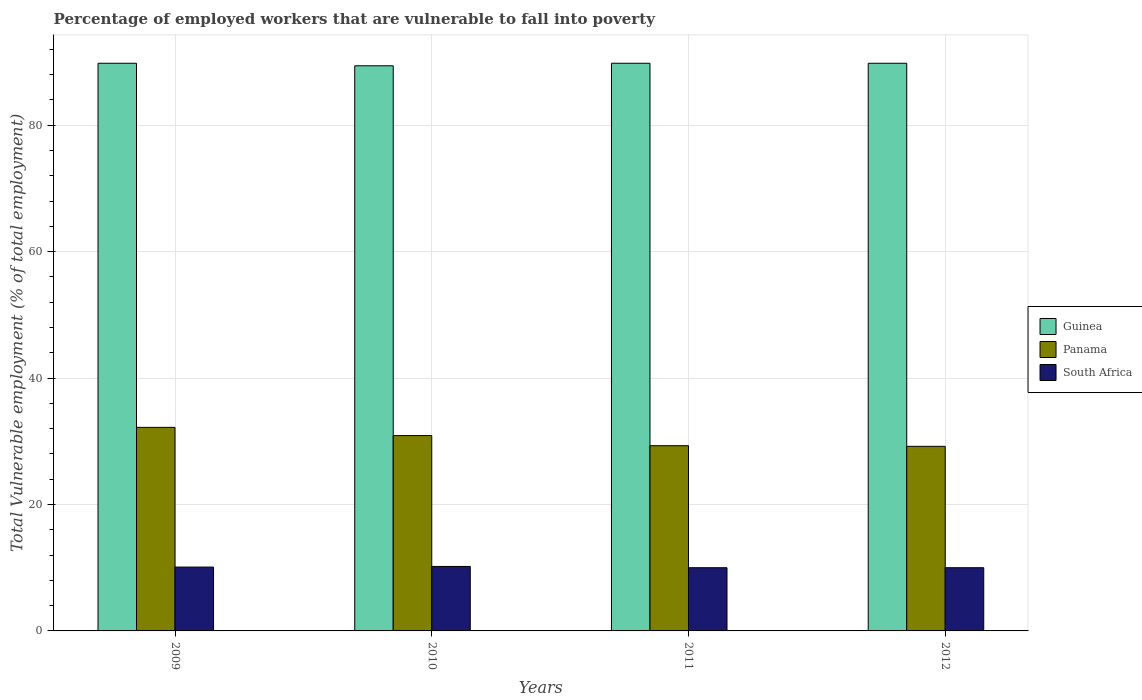What is the label of the 2nd group of bars from the left?
Provide a succinct answer. 2010. Across all years, what is the maximum percentage of employed workers who are vulnerable to fall into poverty in South Africa?
Ensure brevity in your answer.  10.2. Across all years, what is the minimum percentage of employed workers who are vulnerable to fall into poverty in South Africa?
Provide a succinct answer. 10. In which year was the percentage of employed workers who are vulnerable to fall into poverty in South Africa minimum?
Make the answer very short. 2011. What is the total percentage of employed workers who are vulnerable to fall into poverty in Panama in the graph?
Your response must be concise. 121.6. What is the difference between the percentage of employed workers who are vulnerable to fall into poverty in Panama in 2009 and that in 2011?
Offer a very short reply. 2.9. What is the difference between the percentage of employed workers who are vulnerable to fall into poverty in South Africa in 2011 and the percentage of employed workers who are vulnerable to fall into poverty in Panama in 2010?
Ensure brevity in your answer.  -20.9. What is the average percentage of employed workers who are vulnerable to fall into poverty in South Africa per year?
Offer a terse response. 10.08. In the year 2012, what is the difference between the percentage of employed workers who are vulnerable to fall into poverty in Panama and percentage of employed workers who are vulnerable to fall into poverty in Guinea?
Your response must be concise. -60.6. What is the ratio of the percentage of employed workers who are vulnerable to fall into poverty in Guinea in 2011 to that in 2012?
Offer a terse response. 1. Is the percentage of employed workers who are vulnerable to fall into poverty in South Africa in 2009 less than that in 2010?
Keep it short and to the point. Yes. What is the difference between the highest and the lowest percentage of employed workers who are vulnerable to fall into poverty in Guinea?
Offer a very short reply. 0.4. In how many years, is the percentage of employed workers who are vulnerable to fall into poverty in Guinea greater than the average percentage of employed workers who are vulnerable to fall into poverty in Guinea taken over all years?
Give a very brief answer. 3. Is the sum of the percentage of employed workers who are vulnerable to fall into poverty in Guinea in 2010 and 2011 greater than the maximum percentage of employed workers who are vulnerable to fall into poverty in Panama across all years?
Offer a very short reply. Yes. What does the 1st bar from the left in 2009 represents?
Your answer should be compact. Guinea. What does the 3rd bar from the right in 2011 represents?
Give a very brief answer. Guinea. Where does the legend appear in the graph?
Your answer should be compact. Center right. What is the title of the graph?
Make the answer very short. Percentage of employed workers that are vulnerable to fall into poverty. Does "Chile" appear as one of the legend labels in the graph?
Offer a very short reply. No. What is the label or title of the Y-axis?
Offer a very short reply. Total Vulnerable employment (% of total employment). What is the Total Vulnerable employment (% of total employment) of Guinea in 2009?
Provide a succinct answer. 89.8. What is the Total Vulnerable employment (% of total employment) in Panama in 2009?
Offer a very short reply. 32.2. What is the Total Vulnerable employment (% of total employment) of South Africa in 2009?
Your response must be concise. 10.1. What is the Total Vulnerable employment (% of total employment) in Guinea in 2010?
Keep it short and to the point. 89.4. What is the Total Vulnerable employment (% of total employment) in Panama in 2010?
Make the answer very short. 30.9. What is the Total Vulnerable employment (% of total employment) of South Africa in 2010?
Provide a short and direct response. 10.2. What is the Total Vulnerable employment (% of total employment) of Guinea in 2011?
Ensure brevity in your answer.  89.8. What is the Total Vulnerable employment (% of total employment) in Panama in 2011?
Ensure brevity in your answer.  29.3. What is the Total Vulnerable employment (% of total employment) in Guinea in 2012?
Offer a very short reply. 89.8. What is the Total Vulnerable employment (% of total employment) of Panama in 2012?
Offer a very short reply. 29.2. What is the Total Vulnerable employment (% of total employment) in South Africa in 2012?
Give a very brief answer. 10. Across all years, what is the maximum Total Vulnerable employment (% of total employment) of Guinea?
Make the answer very short. 89.8. Across all years, what is the maximum Total Vulnerable employment (% of total employment) in Panama?
Make the answer very short. 32.2. Across all years, what is the maximum Total Vulnerable employment (% of total employment) in South Africa?
Provide a succinct answer. 10.2. Across all years, what is the minimum Total Vulnerable employment (% of total employment) of Guinea?
Your answer should be compact. 89.4. Across all years, what is the minimum Total Vulnerable employment (% of total employment) in Panama?
Your answer should be compact. 29.2. Across all years, what is the minimum Total Vulnerable employment (% of total employment) of South Africa?
Offer a terse response. 10. What is the total Total Vulnerable employment (% of total employment) in Guinea in the graph?
Give a very brief answer. 358.8. What is the total Total Vulnerable employment (% of total employment) in Panama in the graph?
Provide a short and direct response. 121.6. What is the total Total Vulnerable employment (% of total employment) in South Africa in the graph?
Keep it short and to the point. 40.3. What is the difference between the Total Vulnerable employment (% of total employment) of South Africa in 2009 and that in 2010?
Provide a succinct answer. -0.1. What is the difference between the Total Vulnerable employment (% of total employment) of Panama in 2009 and that in 2012?
Ensure brevity in your answer.  3. What is the difference between the Total Vulnerable employment (% of total employment) in South Africa in 2009 and that in 2012?
Your response must be concise. 0.1. What is the difference between the Total Vulnerable employment (% of total employment) in Guinea in 2010 and that in 2011?
Provide a succinct answer. -0.4. What is the difference between the Total Vulnerable employment (% of total employment) in South Africa in 2010 and that in 2011?
Your answer should be very brief. 0.2. What is the difference between the Total Vulnerable employment (% of total employment) in Guinea in 2010 and that in 2012?
Provide a short and direct response. -0.4. What is the difference between the Total Vulnerable employment (% of total employment) of Panama in 2010 and that in 2012?
Provide a short and direct response. 1.7. What is the difference between the Total Vulnerable employment (% of total employment) in Panama in 2011 and that in 2012?
Provide a short and direct response. 0.1. What is the difference between the Total Vulnerable employment (% of total employment) in South Africa in 2011 and that in 2012?
Keep it short and to the point. 0. What is the difference between the Total Vulnerable employment (% of total employment) of Guinea in 2009 and the Total Vulnerable employment (% of total employment) of Panama in 2010?
Give a very brief answer. 58.9. What is the difference between the Total Vulnerable employment (% of total employment) in Guinea in 2009 and the Total Vulnerable employment (% of total employment) in South Africa in 2010?
Keep it short and to the point. 79.6. What is the difference between the Total Vulnerable employment (% of total employment) of Panama in 2009 and the Total Vulnerable employment (% of total employment) of South Africa in 2010?
Your response must be concise. 22. What is the difference between the Total Vulnerable employment (% of total employment) in Guinea in 2009 and the Total Vulnerable employment (% of total employment) in Panama in 2011?
Make the answer very short. 60.5. What is the difference between the Total Vulnerable employment (% of total employment) of Guinea in 2009 and the Total Vulnerable employment (% of total employment) of South Africa in 2011?
Make the answer very short. 79.8. What is the difference between the Total Vulnerable employment (% of total employment) in Guinea in 2009 and the Total Vulnerable employment (% of total employment) in Panama in 2012?
Give a very brief answer. 60.6. What is the difference between the Total Vulnerable employment (% of total employment) of Guinea in 2009 and the Total Vulnerable employment (% of total employment) of South Africa in 2012?
Give a very brief answer. 79.8. What is the difference between the Total Vulnerable employment (% of total employment) of Guinea in 2010 and the Total Vulnerable employment (% of total employment) of Panama in 2011?
Keep it short and to the point. 60.1. What is the difference between the Total Vulnerable employment (% of total employment) in Guinea in 2010 and the Total Vulnerable employment (% of total employment) in South Africa in 2011?
Your response must be concise. 79.4. What is the difference between the Total Vulnerable employment (% of total employment) in Panama in 2010 and the Total Vulnerable employment (% of total employment) in South Africa in 2011?
Offer a terse response. 20.9. What is the difference between the Total Vulnerable employment (% of total employment) of Guinea in 2010 and the Total Vulnerable employment (% of total employment) of Panama in 2012?
Keep it short and to the point. 60.2. What is the difference between the Total Vulnerable employment (% of total employment) in Guinea in 2010 and the Total Vulnerable employment (% of total employment) in South Africa in 2012?
Provide a short and direct response. 79.4. What is the difference between the Total Vulnerable employment (% of total employment) in Panama in 2010 and the Total Vulnerable employment (% of total employment) in South Africa in 2012?
Give a very brief answer. 20.9. What is the difference between the Total Vulnerable employment (% of total employment) of Guinea in 2011 and the Total Vulnerable employment (% of total employment) of Panama in 2012?
Your answer should be very brief. 60.6. What is the difference between the Total Vulnerable employment (% of total employment) in Guinea in 2011 and the Total Vulnerable employment (% of total employment) in South Africa in 2012?
Offer a terse response. 79.8. What is the difference between the Total Vulnerable employment (% of total employment) in Panama in 2011 and the Total Vulnerable employment (% of total employment) in South Africa in 2012?
Your answer should be very brief. 19.3. What is the average Total Vulnerable employment (% of total employment) in Guinea per year?
Provide a short and direct response. 89.7. What is the average Total Vulnerable employment (% of total employment) of Panama per year?
Keep it short and to the point. 30.4. What is the average Total Vulnerable employment (% of total employment) in South Africa per year?
Give a very brief answer. 10.07. In the year 2009, what is the difference between the Total Vulnerable employment (% of total employment) of Guinea and Total Vulnerable employment (% of total employment) of Panama?
Provide a succinct answer. 57.6. In the year 2009, what is the difference between the Total Vulnerable employment (% of total employment) in Guinea and Total Vulnerable employment (% of total employment) in South Africa?
Your answer should be very brief. 79.7. In the year 2009, what is the difference between the Total Vulnerable employment (% of total employment) in Panama and Total Vulnerable employment (% of total employment) in South Africa?
Your response must be concise. 22.1. In the year 2010, what is the difference between the Total Vulnerable employment (% of total employment) of Guinea and Total Vulnerable employment (% of total employment) of Panama?
Your answer should be compact. 58.5. In the year 2010, what is the difference between the Total Vulnerable employment (% of total employment) of Guinea and Total Vulnerable employment (% of total employment) of South Africa?
Offer a very short reply. 79.2. In the year 2010, what is the difference between the Total Vulnerable employment (% of total employment) in Panama and Total Vulnerable employment (% of total employment) in South Africa?
Offer a terse response. 20.7. In the year 2011, what is the difference between the Total Vulnerable employment (% of total employment) of Guinea and Total Vulnerable employment (% of total employment) of Panama?
Give a very brief answer. 60.5. In the year 2011, what is the difference between the Total Vulnerable employment (% of total employment) of Guinea and Total Vulnerable employment (% of total employment) of South Africa?
Ensure brevity in your answer.  79.8. In the year 2011, what is the difference between the Total Vulnerable employment (% of total employment) of Panama and Total Vulnerable employment (% of total employment) of South Africa?
Offer a terse response. 19.3. In the year 2012, what is the difference between the Total Vulnerable employment (% of total employment) of Guinea and Total Vulnerable employment (% of total employment) of Panama?
Keep it short and to the point. 60.6. In the year 2012, what is the difference between the Total Vulnerable employment (% of total employment) in Guinea and Total Vulnerable employment (% of total employment) in South Africa?
Provide a succinct answer. 79.8. What is the ratio of the Total Vulnerable employment (% of total employment) of Panama in 2009 to that in 2010?
Provide a succinct answer. 1.04. What is the ratio of the Total Vulnerable employment (% of total employment) in South Africa in 2009 to that in 2010?
Your answer should be compact. 0.99. What is the ratio of the Total Vulnerable employment (% of total employment) in Panama in 2009 to that in 2011?
Make the answer very short. 1.1. What is the ratio of the Total Vulnerable employment (% of total employment) in Panama in 2009 to that in 2012?
Give a very brief answer. 1.1. What is the ratio of the Total Vulnerable employment (% of total employment) in Panama in 2010 to that in 2011?
Your response must be concise. 1.05. What is the ratio of the Total Vulnerable employment (% of total employment) in South Africa in 2010 to that in 2011?
Provide a short and direct response. 1.02. What is the ratio of the Total Vulnerable employment (% of total employment) in Panama in 2010 to that in 2012?
Ensure brevity in your answer.  1.06. What is the ratio of the Total Vulnerable employment (% of total employment) in South Africa in 2010 to that in 2012?
Provide a short and direct response. 1.02. What is the ratio of the Total Vulnerable employment (% of total employment) of Panama in 2011 to that in 2012?
Provide a short and direct response. 1. What is the ratio of the Total Vulnerable employment (% of total employment) of South Africa in 2011 to that in 2012?
Offer a terse response. 1. What is the difference between the highest and the second highest Total Vulnerable employment (% of total employment) in Panama?
Offer a very short reply. 1.3. What is the difference between the highest and the second highest Total Vulnerable employment (% of total employment) of South Africa?
Your answer should be very brief. 0.1. What is the difference between the highest and the lowest Total Vulnerable employment (% of total employment) of Panama?
Your answer should be compact. 3. What is the difference between the highest and the lowest Total Vulnerable employment (% of total employment) in South Africa?
Offer a very short reply. 0.2. 